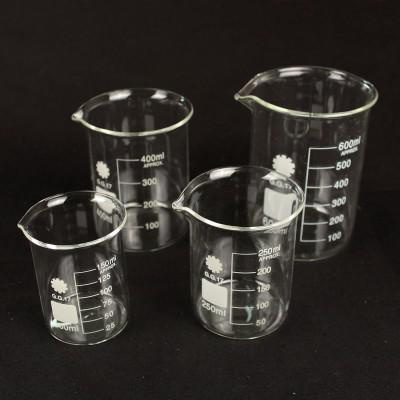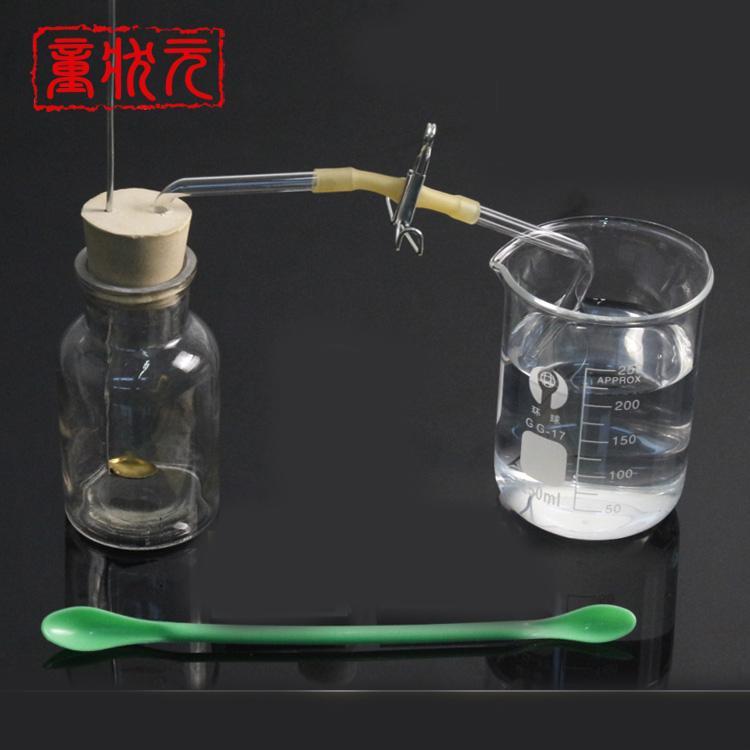The first image is the image on the left, the second image is the image on the right. Considering the images on both sides, is "There are exactly three flasks in the image on the left." valid? Answer yes or no. No. 